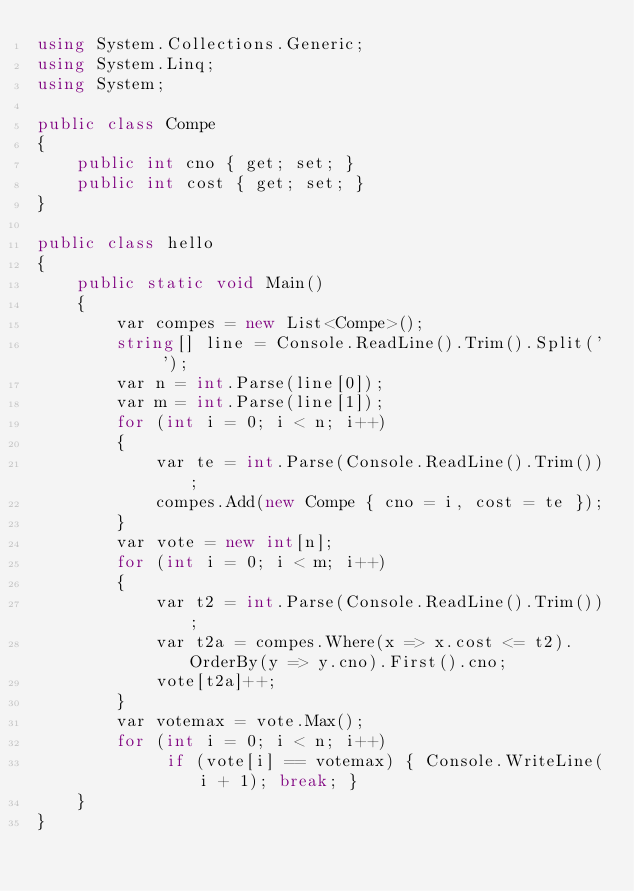<code> <loc_0><loc_0><loc_500><loc_500><_C#_>using System.Collections.Generic;
using System.Linq;
using System;

public class Compe
{
    public int cno { get; set; }
    public int cost { get; set; }
}

public class hello
{
    public static void Main()
    {
        var compes = new List<Compe>();
        string[] line = Console.ReadLine().Trim().Split(' ');
        var n = int.Parse(line[0]);
        var m = int.Parse(line[1]);
        for (int i = 0; i < n; i++)
        {
            var te = int.Parse(Console.ReadLine().Trim());
            compes.Add(new Compe { cno = i, cost = te });
        }
        var vote = new int[n];
        for (int i = 0; i < m; i++)
        {
            var t2 = int.Parse(Console.ReadLine().Trim());
            var t2a = compes.Where(x => x.cost <= t2).OrderBy(y => y.cno).First().cno;
            vote[t2a]++;
        }
        var votemax = vote.Max();
        for (int i = 0; i < n; i++)
             if (vote[i] == votemax) { Console.WriteLine(i + 1); break; }
    }
}</code> 